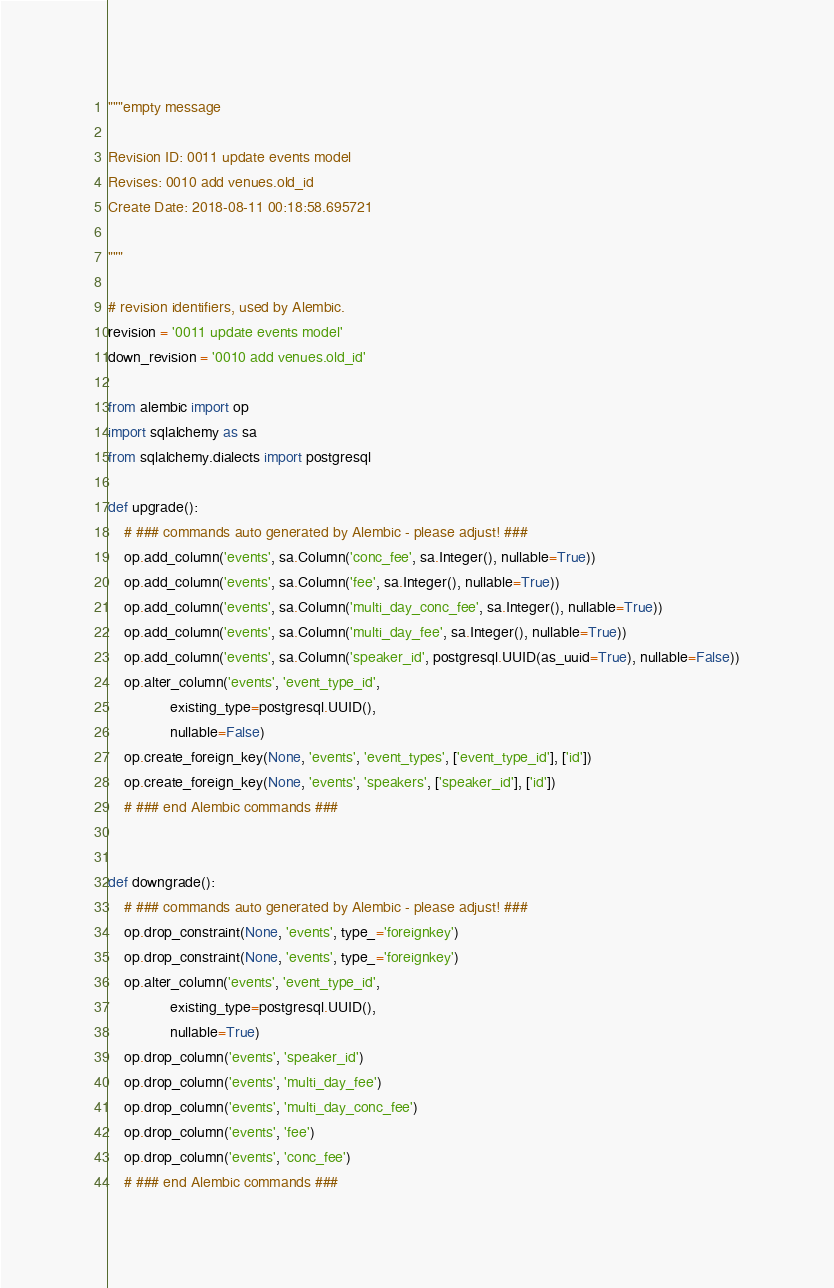<code> <loc_0><loc_0><loc_500><loc_500><_Python_>"""empty message

Revision ID: 0011 update events model
Revises: 0010 add venues.old_id
Create Date: 2018-08-11 00:18:58.695721

"""

# revision identifiers, used by Alembic.
revision = '0011 update events model'
down_revision = '0010 add venues.old_id'

from alembic import op
import sqlalchemy as sa
from sqlalchemy.dialects import postgresql

def upgrade():
    # ### commands auto generated by Alembic - please adjust! ###
    op.add_column('events', sa.Column('conc_fee', sa.Integer(), nullable=True))
    op.add_column('events', sa.Column('fee', sa.Integer(), nullable=True))
    op.add_column('events', sa.Column('multi_day_conc_fee', sa.Integer(), nullable=True))
    op.add_column('events', sa.Column('multi_day_fee', sa.Integer(), nullable=True))
    op.add_column('events', sa.Column('speaker_id', postgresql.UUID(as_uuid=True), nullable=False))
    op.alter_column('events', 'event_type_id',
               existing_type=postgresql.UUID(),
               nullable=False)
    op.create_foreign_key(None, 'events', 'event_types', ['event_type_id'], ['id'])
    op.create_foreign_key(None, 'events', 'speakers', ['speaker_id'], ['id'])
    # ### end Alembic commands ###


def downgrade():
    # ### commands auto generated by Alembic - please adjust! ###
    op.drop_constraint(None, 'events', type_='foreignkey')
    op.drop_constraint(None, 'events', type_='foreignkey')
    op.alter_column('events', 'event_type_id',
               existing_type=postgresql.UUID(),
               nullable=True)
    op.drop_column('events', 'speaker_id')
    op.drop_column('events', 'multi_day_fee')
    op.drop_column('events', 'multi_day_conc_fee')
    op.drop_column('events', 'fee')
    op.drop_column('events', 'conc_fee')
    # ### end Alembic commands ###
</code> 